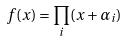Convert formula to latex. <formula><loc_0><loc_0><loc_500><loc_500>f ( x ) = \prod _ { i } ( x + \alpha _ { i } )</formula> 